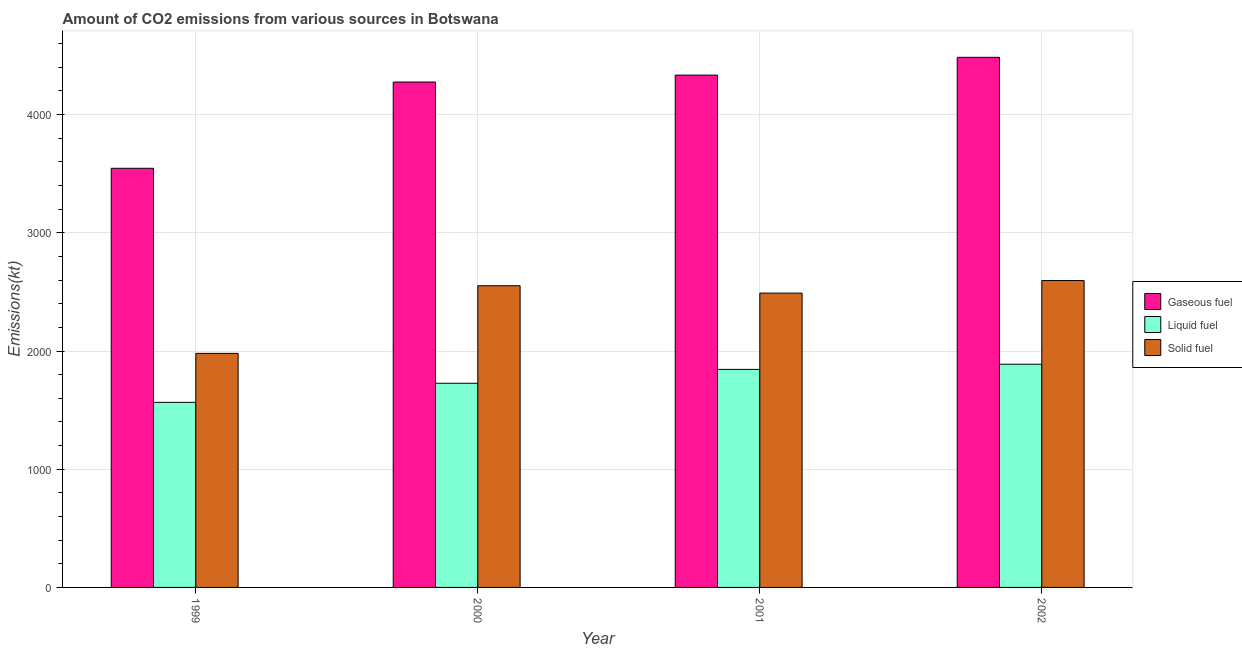How many different coloured bars are there?
Provide a short and direct response. 3. How many groups of bars are there?
Make the answer very short. 4. Are the number of bars per tick equal to the number of legend labels?
Keep it short and to the point. Yes. In how many cases, is the number of bars for a given year not equal to the number of legend labels?
Ensure brevity in your answer.  0. What is the amount of co2 emissions from gaseous fuel in 2001?
Provide a short and direct response. 4334.39. Across all years, what is the maximum amount of co2 emissions from solid fuel?
Your response must be concise. 2596.24. Across all years, what is the minimum amount of co2 emissions from solid fuel?
Provide a succinct answer. 1980.18. In which year was the amount of co2 emissions from liquid fuel minimum?
Keep it short and to the point. 1999. What is the total amount of co2 emissions from solid fuel in the graph?
Your response must be concise. 9618.54. What is the difference between the amount of co2 emissions from solid fuel in 2000 and that in 2001?
Offer a very short reply. 62.34. What is the difference between the amount of co2 emissions from gaseous fuel in 1999 and the amount of co2 emissions from liquid fuel in 2001?
Your answer should be compact. -788.41. What is the average amount of co2 emissions from gaseous fuel per year?
Offer a terse response. 4160.21. What is the ratio of the amount of co2 emissions from solid fuel in 1999 to that in 2001?
Give a very brief answer. 0.8. Is the amount of co2 emissions from solid fuel in 1999 less than that in 2001?
Provide a succinct answer. Yes. What is the difference between the highest and the second highest amount of co2 emissions from gaseous fuel?
Provide a short and direct response. 150.35. What is the difference between the highest and the lowest amount of co2 emissions from liquid fuel?
Ensure brevity in your answer.  322.7. Is the sum of the amount of co2 emissions from solid fuel in 2000 and 2001 greater than the maximum amount of co2 emissions from liquid fuel across all years?
Your answer should be very brief. Yes. What does the 1st bar from the left in 2002 represents?
Give a very brief answer. Gaseous fuel. What does the 1st bar from the right in 2000 represents?
Ensure brevity in your answer.  Solid fuel. How many bars are there?
Your response must be concise. 12. What is the difference between two consecutive major ticks on the Y-axis?
Offer a very short reply. 1000. Does the graph contain grids?
Give a very brief answer. Yes. How are the legend labels stacked?
Your answer should be very brief. Vertical. What is the title of the graph?
Your answer should be compact. Amount of CO2 emissions from various sources in Botswana. Does "Nuclear sources" appear as one of the legend labels in the graph?
Ensure brevity in your answer.  No. What is the label or title of the X-axis?
Make the answer very short. Year. What is the label or title of the Y-axis?
Your answer should be compact. Emissions(kt). What is the Emissions(kt) in Gaseous fuel in 1999?
Make the answer very short. 3545.99. What is the Emissions(kt) in Liquid fuel in 1999?
Make the answer very short. 1565.81. What is the Emissions(kt) in Solid fuel in 1999?
Your answer should be very brief. 1980.18. What is the Emissions(kt) of Gaseous fuel in 2000?
Make the answer very short. 4275.72. What is the Emissions(kt) of Liquid fuel in 2000?
Your answer should be compact. 1727.16. What is the Emissions(kt) of Solid fuel in 2000?
Provide a short and direct response. 2552.23. What is the Emissions(kt) of Gaseous fuel in 2001?
Provide a succinct answer. 4334.39. What is the Emissions(kt) in Liquid fuel in 2001?
Offer a terse response. 1844.5. What is the Emissions(kt) of Solid fuel in 2001?
Provide a succinct answer. 2489.89. What is the Emissions(kt) in Gaseous fuel in 2002?
Your answer should be compact. 4484.74. What is the Emissions(kt) in Liquid fuel in 2002?
Give a very brief answer. 1888.51. What is the Emissions(kt) in Solid fuel in 2002?
Your answer should be very brief. 2596.24. Across all years, what is the maximum Emissions(kt) of Gaseous fuel?
Provide a short and direct response. 4484.74. Across all years, what is the maximum Emissions(kt) of Liquid fuel?
Offer a very short reply. 1888.51. Across all years, what is the maximum Emissions(kt) of Solid fuel?
Keep it short and to the point. 2596.24. Across all years, what is the minimum Emissions(kt) of Gaseous fuel?
Provide a succinct answer. 3545.99. Across all years, what is the minimum Emissions(kt) in Liquid fuel?
Make the answer very short. 1565.81. Across all years, what is the minimum Emissions(kt) of Solid fuel?
Offer a very short reply. 1980.18. What is the total Emissions(kt) in Gaseous fuel in the graph?
Provide a succinct answer. 1.66e+04. What is the total Emissions(kt) of Liquid fuel in the graph?
Ensure brevity in your answer.  7025.97. What is the total Emissions(kt) of Solid fuel in the graph?
Provide a succinct answer. 9618.54. What is the difference between the Emissions(kt) in Gaseous fuel in 1999 and that in 2000?
Provide a short and direct response. -729.73. What is the difference between the Emissions(kt) of Liquid fuel in 1999 and that in 2000?
Your answer should be compact. -161.35. What is the difference between the Emissions(kt) in Solid fuel in 1999 and that in 2000?
Your answer should be compact. -572.05. What is the difference between the Emissions(kt) of Gaseous fuel in 1999 and that in 2001?
Offer a terse response. -788.4. What is the difference between the Emissions(kt) in Liquid fuel in 1999 and that in 2001?
Keep it short and to the point. -278.69. What is the difference between the Emissions(kt) in Solid fuel in 1999 and that in 2001?
Your answer should be very brief. -509.71. What is the difference between the Emissions(kt) in Gaseous fuel in 1999 and that in 2002?
Your answer should be very brief. -938.75. What is the difference between the Emissions(kt) of Liquid fuel in 1999 and that in 2002?
Offer a terse response. -322.7. What is the difference between the Emissions(kt) of Solid fuel in 1999 and that in 2002?
Your answer should be very brief. -616.06. What is the difference between the Emissions(kt) of Gaseous fuel in 2000 and that in 2001?
Keep it short and to the point. -58.67. What is the difference between the Emissions(kt) of Liquid fuel in 2000 and that in 2001?
Your response must be concise. -117.34. What is the difference between the Emissions(kt) of Solid fuel in 2000 and that in 2001?
Keep it short and to the point. 62.34. What is the difference between the Emissions(kt) in Gaseous fuel in 2000 and that in 2002?
Your answer should be compact. -209.02. What is the difference between the Emissions(kt) of Liquid fuel in 2000 and that in 2002?
Keep it short and to the point. -161.35. What is the difference between the Emissions(kt) in Solid fuel in 2000 and that in 2002?
Your response must be concise. -44. What is the difference between the Emissions(kt) in Gaseous fuel in 2001 and that in 2002?
Your answer should be compact. -150.35. What is the difference between the Emissions(kt) in Liquid fuel in 2001 and that in 2002?
Offer a very short reply. -44. What is the difference between the Emissions(kt) in Solid fuel in 2001 and that in 2002?
Offer a very short reply. -106.34. What is the difference between the Emissions(kt) in Gaseous fuel in 1999 and the Emissions(kt) in Liquid fuel in 2000?
Your answer should be very brief. 1818.83. What is the difference between the Emissions(kt) of Gaseous fuel in 1999 and the Emissions(kt) of Solid fuel in 2000?
Give a very brief answer. 993.76. What is the difference between the Emissions(kt) of Liquid fuel in 1999 and the Emissions(kt) of Solid fuel in 2000?
Your response must be concise. -986.42. What is the difference between the Emissions(kt) in Gaseous fuel in 1999 and the Emissions(kt) in Liquid fuel in 2001?
Make the answer very short. 1701.49. What is the difference between the Emissions(kt) of Gaseous fuel in 1999 and the Emissions(kt) of Solid fuel in 2001?
Provide a succinct answer. 1056.1. What is the difference between the Emissions(kt) in Liquid fuel in 1999 and the Emissions(kt) in Solid fuel in 2001?
Provide a succinct answer. -924.08. What is the difference between the Emissions(kt) in Gaseous fuel in 1999 and the Emissions(kt) in Liquid fuel in 2002?
Give a very brief answer. 1657.48. What is the difference between the Emissions(kt) of Gaseous fuel in 1999 and the Emissions(kt) of Solid fuel in 2002?
Offer a very short reply. 949.75. What is the difference between the Emissions(kt) in Liquid fuel in 1999 and the Emissions(kt) in Solid fuel in 2002?
Your answer should be very brief. -1030.43. What is the difference between the Emissions(kt) of Gaseous fuel in 2000 and the Emissions(kt) of Liquid fuel in 2001?
Offer a very short reply. 2431.22. What is the difference between the Emissions(kt) of Gaseous fuel in 2000 and the Emissions(kt) of Solid fuel in 2001?
Your response must be concise. 1785.83. What is the difference between the Emissions(kt) of Liquid fuel in 2000 and the Emissions(kt) of Solid fuel in 2001?
Your response must be concise. -762.74. What is the difference between the Emissions(kt) in Gaseous fuel in 2000 and the Emissions(kt) in Liquid fuel in 2002?
Offer a terse response. 2387.22. What is the difference between the Emissions(kt) of Gaseous fuel in 2000 and the Emissions(kt) of Solid fuel in 2002?
Provide a succinct answer. 1679.49. What is the difference between the Emissions(kt) in Liquid fuel in 2000 and the Emissions(kt) in Solid fuel in 2002?
Your answer should be very brief. -869.08. What is the difference between the Emissions(kt) of Gaseous fuel in 2001 and the Emissions(kt) of Liquid fuel in 2002?
Provide a succinct answer. 2445.89. What is the difference between the Emissions(kt) in Gaseous fuel in 2001 and the Emissions(kt) in Solid fuel in 2002?
Ensure brevity in your answer.  1738.16. What is the difference between the Emissions(kt) in Liquid fuel in 2001 and the Emissions(kt) in Solid fuel in 2002?
Your answer should be compact. -751.74. What is the average Emissions(kt) of Gaseous fuel per year?
Your answer should be very brief. 4160.21. What is the average Emissions(kt) in Liquid fuel per year?
Keep it short and to the point. 1756.49. What is the average Emissions(kt) in Solid fuel per year?
Ensure brevity in your answer.  2404.64. In the year 1999, what is the difference between the Emissions(kt) in Gaseous fuel and Emissions(kt) in Liquid fuel?
Your response must be concise. 1980.18. In the year 1999, what is the difference between the Emissions(kt) in Gaseous fuel and Emissions(kt) in Solid fuel?
Offer a very short reply. 1565.81. In the year 1999, what is the difference between the Emissions(kt) in Liquid fuel and Emissions(kt) in Solid fuel?
Offer a terse response. -414.37. In the year 2000, what is the difference between the Emissions(kt) in Gaseous fuel and Emissions(kt) in Liquid fuel?
Your answer should be very brief. 2548.57. In the year 2000, what is the difference between the Emissions(kt) in Gaseous fuel and Emissions(kt) in Solid fuel?
Your response must be concise. 1723.49. In the year 2000, what is the difference between the Emissions(kt) in Liquid fuel and Emissions(kt) in Solid fuel?
Keep it short and to the point. -825.08. In the year 2001, what is the difference between the Emissions(kt) in Gaseous fuel and Emissions(kt) in Liquid fuel?
Your answer should be very brief. 2489.89. In the year 2001, what is the difference between the Emissions(kt) in Gaseous fuel and Emissions(kt) in Solid fuel?
Make the answer very short. 1844.5. In the year 2001, what is the difference between the Emissions(kt) in Liquid fuel and Emissions(kt) in Solid fuel?
Your answer should be compact. -645.39. In the year 2002, what is the difference between the Emissions(kt) of Gaseous fuel and Emissions(kt) of Liquid fuel?
Give a very brief answer. 2596.24. In the year 2002, what is the difference between the Emissions(kt) in Gaseous fuel and Emissions(kt) in Solid fuel?
Offer a very short reply. 1888.51. In the year 2002, what is the difference between the Emissions(kt) in Liquid fuel and Emissions(kt) in Solid fuel?
Provide a short and direct response. -707.73. What is the ratio of the Emissions(kt) in Gaseous fuel in 1999 to that in 2000?
Your answer should be very brief. 0.83. What is the ratio of the Emissions(kt) in Liquid fuel in 1999 to that in 2000?
Make the answer very short. 0.91. What is the ratio of the Emissions(kt) in Solid fuel in 1999 to that in 2000?
Your response must be concise. 0.78. What is the ratio of the Emissions(kt) of Gaseous fuel in 1999 to that in 2001?
Give a very brief answer. 0.82. What is the ratio of the Emissions(kt) of Liquid fuel in 1999 to that in 2001?
Your answer should be compact. 0.85. What is the ratio of the Emissions(kt) of Solid fuel in 1999 to that in 2001?
Your answer should be compact. 0.8. What is the ratio of the Emissions(kt) in Gaseous fuel in 1999 to that in 2002?
Give a very brief answer. 0.79. What is the ratio of the Emissions(kt) of Liquid fuel in 1999 to that in 2002?
Your answer should be very brief. 0.83. What is the ratio of the Emissions(kt) in Solid fuel in 1999 to that in 2002?
Ensure brevity in your answer.  0.76. What is the ratio of the Emissions(kt) in Gaseous fuel in 2000 to that in 2001?
Provide a succinct answer. 0.99. What is the ratio of the Emissions(kt) of Liquid fuel in 2000 to that in 2001?
Your answer should be compact. 0.94. What is the ratio of the Emissions(kt) of Gaseous fuel in 2000 to that in 2002?
Offer a terse response. 0.95. What is the ratio of the Emissions(kt) in Liquid fuel in 2000 to that in 2002?
Provide a succinct answer. 0.91. What is the ratio of the Emissions(kt) in Solid fuel in 2000 to that in 2002?
Provide a succinct answer. 0.98. What is the ratio of the Emissions(kt) in Gaseous fuel in 2001 to that in 2002?
Your answer should be compact. 0.97. What is the ratio of the Emissions(kt) in Liquid fuel in 2001 to that in 2002?
Ensure brevity in your answer.  0.98. What is the ratio of the Emissions(kt) in Solid fuel in 2001 to that in 2002?
Offer a very short reply. 0.96. What is the difference between the highest and the second highest Emissions(kt) in Gaseous fuel?
Your answer should be compact. 150.35. What is the difference between the highest and the second highest Emissions(kt) in Liquid fuel?
Ensure brevity in your answer.  44. What is the difference between the highest and the second highest Emissions(kt) in Solid fuel?
Provide a succinct answer. 44. What is the difference between the highest and the lowest Emissions(kt) in Gaseous fuel?
Offer a terse response. 938.75. What is the difference between the highest and the lowest Emissions(kt) of Liquid fuel?
Your answer should be compact. 322.7. What is the difference between the highest and the lowest Emissions(kt) in Solid fuel?
Give a very brief answer. 616.06. 